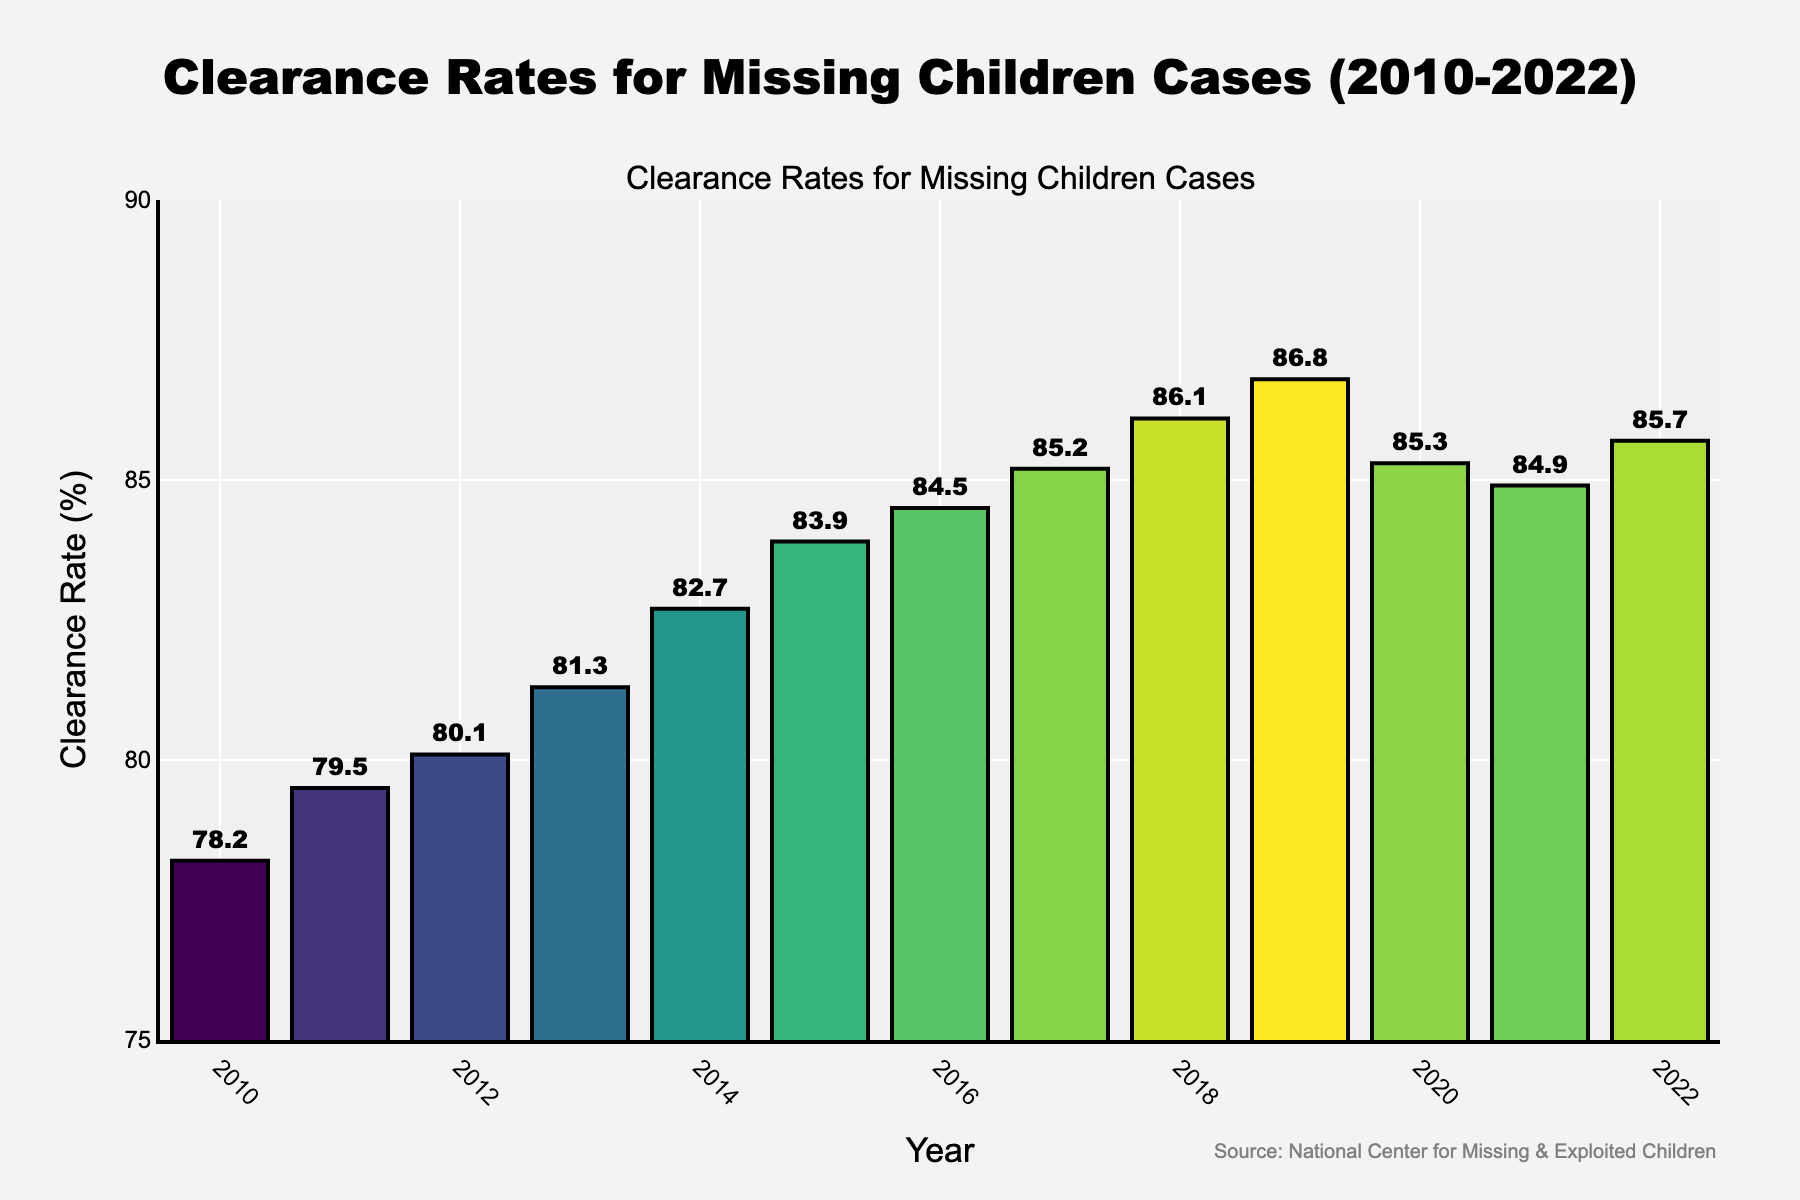which year had the highest clearance rate? To find the year with the highest clearance rate, look for the tallest bar on the chart. The year at the highest bar's base indicates the highest clearance rate.
Answer: 2019 how much did the clearance rate increase from 2010 to 2019? Subtract the clearance rate in 2010 from the clearance rate in 2019. Clearance Rate for 2019: 86.8%, Clearance Rate for 2010: 78.2%. So, 86.8 - 78.2 = 8.6%.
Answer: 8.6% what is the average clearance rate from 2010 to 2022? Add up all the clearance rates from 2010 to 2022 and divide by the number of years, which is 13. (78.2 + 79.5 + 80.1 + 81.3 + 82.7 + 83.9 + 84.5 + 85.2 + 86.1 + 86.8 + 85.3 + 84.9 + 85.7) / 13 = 82.8%
Answer: 82.8% compare the clearance rate between 2013 and 2021. Which year had a higher rate? Look at the bar heights for 2013 and 2021. Check the clearance rates: 2013 had 81.3%, and 2021 had 84.9%. Since 84.9% is higher, 2021 had a higher rate.
Answer: 2021 what is the median clearance rate from 2010 to 2022? To find the median, list the rates in ascending order and find the middle value. The data points are: 78.2, 79.5, 80.1, 81.3, 82.7, 83.9, 84.5, 84.9, 85.2, 85.3, 85.7, 86.1, 86.8%. The middle value (7th in this 13-element list) is 84.5%.
Answer: 84.5% in which year did the clearance rate decrease compared to the previous year? Look for bars that are shorter than the previous bar. From 2019 to 2020, the clearance rate dropped from 86.8% to 85.3%.
Answer: 2020 what was the clearance rate trend from 2010 to 2022? Observe the overall direction of the bars from left to right. Initially, the clearance rate increased each year from 2010 to 2019, then slightly fluctuated with a minor drop in 2020 before rising again towards 2022.
Answer: Increasing trend with minor fluctuations how many years did the clearance rate stay above 85%? Count the years where the clearance rate is above 85%. These years are: 2018, 2019, 2020, 2021, 2022. That makes a total of 5 years.
Answer: 5 